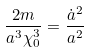<formula> <loc_0><loc_0><loc_500><loc_500>\frac { 2 m } { a ^ { 3 } \chi _ { 0 } ^ { 3 } } = \frac { \dot { a } ^ { 2 } } { a ^ { 2 } }</formula> 